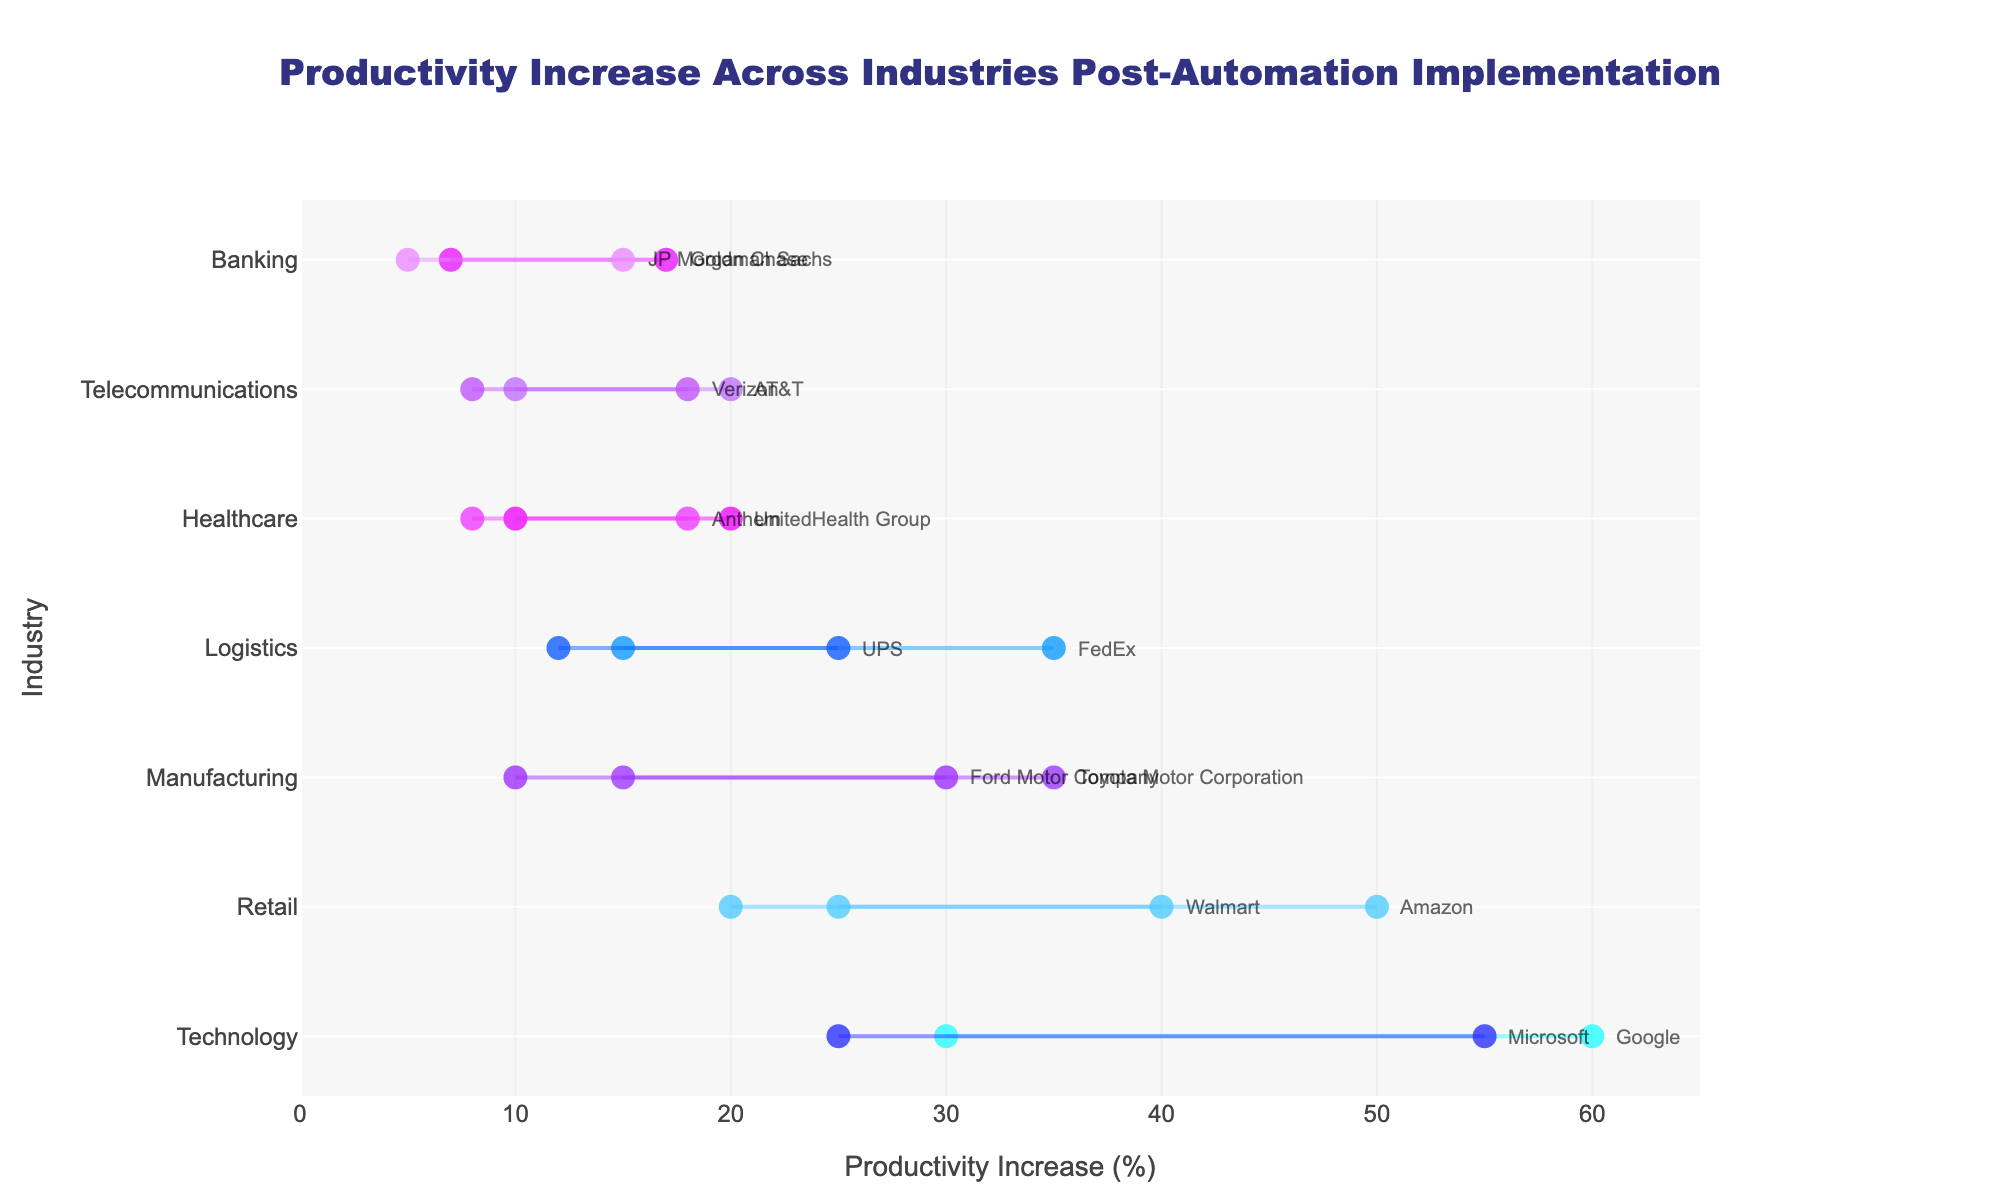What is the highest maximum productivity increase shown in the plot? From the figure, the maximum productivity increase is represented by the far-right data point. Google's productivity increase touches the highest mark at 60%.
Answer: 60% Which industry shows the widest range of productivity increase? The widest range can be determined by comparing the span between the minimum and maximum productivity increases for each industry. The Technology industry, represented by Google (30% to 60%) and Microsoft (25% to 55%), shows the widest range of 30%.
Answer: Technology How do the productivity increases of Amazon and Walmart compare? Amazon's increase ranges from 25% to 50%, while Walmart's ranges from 20% to 40%. Both have overlapping ranges, but Amazon's upper limit is higher by 10%.
Answer: Amazon has a higher upper limit Which company in the Banking industry has the higher minimum productivity increase? JP Morgan Chase has a minimum productivity increase of 5%, while Goldman Sachs has 7%. Therefore, Goldman Sachs has a higher minimum productivity increase.
Answer: Goldman Sachs What is the smallest maximum productivity increase, and which company does it belong to? The smallest maximum productivity increase is the data point closest to the left end of the plot. Anthem in the Healthcare industry has the smallest maximum increase at 18%.
Answer: Anthem at 18% Which industry has the least variation in productivity increases between its companies? By examining the ranges between the minimum and maximum productivity increases among companies within each industry, the Healthcare industry (UnitedHealth Group and Anthem, both ranging between approximately 8%-20%) shows the least variation.
Answer: Healthcare Which industry has the overall highest productivity increase range? Adding both the minimum and maximum increases of all companies within each industry, Technology (Google: 30%-60%, Microsoft: 25%-55%) sums up to the highest overall range.
Answer: Technology What is the average productivity increase range for the Retail industry? For Amazon, the range is (50 - 25 = 25%), and for Walmart, it is (40 - 20 = 20%). The average of these ranges is (25 + 20) / 2 = 22.5%.
Answer: 22.5% How does the productivity increase for UPS compare to that of FedEx in the Logistics industry? UPS has a productivity increase range of 12% to 25%, while FedEx has 15% to 35%, showing that FedEx has a higher upper limit and a higher minimum as well.
Answer: FedEx has higher values What is the average maximum productivity increase across all industries? Summing the maximum increases of all companies and dividing by the number of companies, the calculation is (30 + 35 + 50 + 40 + 20 + 18 + 15 + 17 + 60 + 55 + 25 + 35 + 20 + 18)/14 = 31.07%.
Answer: 31.07% 